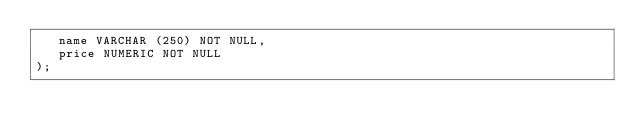Convert code to text. <code><loc_0><loc_0><loc_500><loc_500><_SQL_>   name VARCHAR (250) NOT NULL,
   price NUMERIC NOT NULL
);</code> 